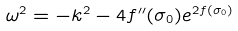Convert formula to latex. <formula><loc_0><loc_0><loc_500><loc_500>\omega ^ { 2 } = - k ^ { 2 } - 4 f ^ { \prime \prime } ( \sigma _ { 0 } ) e ^ { 2 f ( \sigma _ { 0 } ) }</formula> 